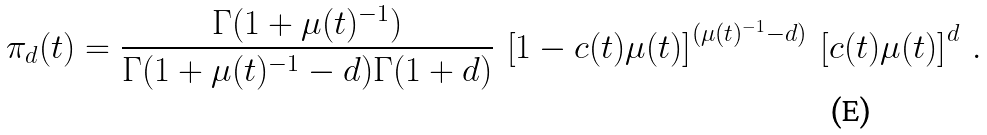Convert formula to latex. <formula><loc_0><loc_0><loc_500><loc_500>\pi _ { d } ( t ) = \frac { \Gamma ( 1 + \mu ( t ) ^ { - 1 } ) } { \Gamma ( 1 + \mu ( t ) ^ { - 1 } - d ) \Gamma ( 1 + d ) } \ \left [ 1 - c ( t ) \mu ( t ) \right ] ^ { ( \mu ( t ) ^ { - 1 } - d ) } \ \left [ c ( t ) \mu ( t ) \right ] ^ { d } \ .</formula> 